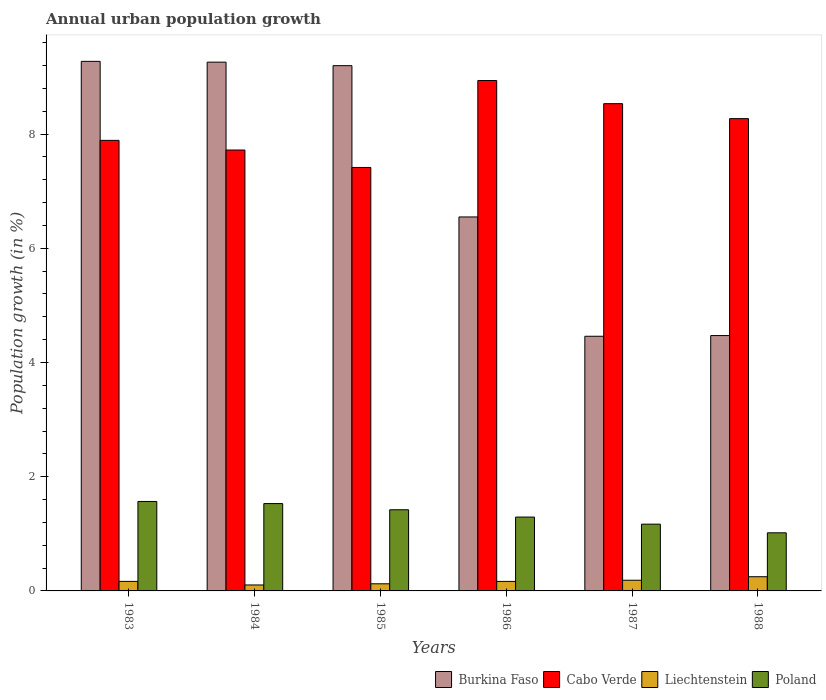How many different coloured bars are there?
Your answer should be compact. 4. Are the number of bars per tick equal to the number of legend labels?
Provide a succinct answer. Yes. What is the label of the 6th group of bars from the left?
Offer a terse response. 1988. What is the percentage of urban population growth in Liechtenstein in 1984?
Keep it short and to the point. 0.1. Across all years, what is the maximum percentage of urban population growth in Poland?
Keep it short and to the point. 1.57. Across all years, what is the minimum percentage of urban population growth in Liechtenstein?
Make the answer very short. 0.1. In which year was the percentage of urban population growth in Burkina Faso maximum?
Your response must be concise. 1983. What is the total percentage of urban population growth in Poland in the graph?
Provide a short and direct response. 8. What is the difference between the percentage of urban population growth in Poland in 1984 and that in 1987?
Make the answer very short. 0.36. What is the difference between the percentage of urban population growth in Burkina Faso in 1988 and the percentage of urban population growth in Poland in 1987?
Keep it short and to the point. 3.3. What is the average percentage of urban population growth in Burkina Faso per year?
Your response must be concise. 7.2. In the year 1984, what is the difference between the percentage of urban population growth in Burkina Faso and percentage of urban population growth in Liechtenstein?
Make the answer very short. 9.15. What is the ratio of the percentage of urban population growth in Cabo Verde in 1984 to that in 1988?
Keep it short and to the point. 0.93. Is the percentage of urban population growth in Burkina Faso in 1987 less than that in 1988?
Your answer should be very brief. Yes. Is the difference between the percentage of urban population growth in Burkina Faso in 1984 and 1986 greater than the difference between the percentage of urban population growth in Liechtenstein in 1984 and 1986?
Ensure brevity in your answer.  Yes. What is the difference between the highest and the second highest percentage of urban population growth in Poland?
Your response must be concise. 0.04. What is the difference between the highest and the lowest percentage of urban population growth in Burkina Faso?
Make the answer very short. 4.81. In how many years, is the percentage of urban population growth in Poland greater than the average percentage of urban population growth in Poland taken over all years?
Offer a very short reply. 3. Is it the case that in every year, the sum of the percentage of urban population growth in Poland and percentage of urban population growth in Burkina Faso is greater than the sum of percentage of urban population growth in Cabo Verde and percentage of urban population growth in Liechtenstein?
Provide a succinct answer. Yes. What does the 3rd bar from the left in 1987 represents?
Offer a very short reply. Liechtenstein. What does the 2nd bar from the right in 1983 represents?
Give a very brief answer. Liechtenstein. Is it the case that in every year, the sum of the percentage of urban population growth in Burkina Faso and percentage of urban population growth in Poland is greater than the percentage of urban population growth in Cabo Verde?
Keep it short and to the point. No. How many bars are there?
Provide a succinct answer. 24. How many years are there in the graph?
Provide a succinct answer. 6. Are the values on the major ticks of Y-axis written in scientific E-notation?
Your response must be concise. No. Does the graph contain grids?
Provide a short and direct response. No. What is the title of the graph?
Keep it short and to the point. Annual urban population growth. Does "Fiji" appear as one of the legend labels in the graph?
Make the answer very short. No. What is the label or title of the Y-axis?
Your answer should be compact. Population growth (in %). What is the Population growth (in %) in Burkina Faso in 1983?
Your response must be concise. 9.27. What is the Population growth (in %) in Cabo Verde in 1983?
Your answer should be very brief. 7.89. What is the Population growth (in %) of Liechtenstein in 1983?
Make the answer very short. 0.17. What is the Population growth (in %) in Poland in 1983?
Your answer should be very brief. 1.57. What is the Population growth (in %) in Burkina Faso in 1984?
Offer a terse response. 9.26. What is the Population growth (in %) of Cabo Verde in 1984?
Provide a short and direct response. 7.72. What is the Population growth (in %) in Liechtenstein in 1984?
Your response must be concise. 0.1. What is the Population growth (in %) of Poland in 1984?
Your answer should be compact. 1.53. What is the Population growth (in %) of Burkina Faso in 1985?
Your response must be concise. 9.2. What is the Population growth (in %) of Cabo Verde in 1985?
Keep it short and to the point. 7.41. What is the Population growth (in %) in Liechtenstein in 1985?
Provide a short and direct response. 0.13. What is the Population growth (in %) in Poland in 1985?
Your answer should be compact. 1.42. What is the Population growth (in %) of Burkina Faso in 1986?
Your answer should be very brief. 6.55. What is the Population growth (in %) in Cabo Verde in 1986?
Your response must be concise. 8.94. What is the Population growth (in %) in Liechtenstein in 1986?
Provide a succinct answer. 0.17. What is the Population growth (in %) in Poland in 1986?
Provide a succinct answer. 1.29. What is the Population growth (in %) in Burkina Faso in 1987?
Provide a short and direct response. 4.46. What is the Population growth (in %) of Cabo Verde in 1987?
Your answer should be compact. 8.53. What is the Population growth (in %) in Liechtenstein in 1987?
Provide a succinct answer. 0.19. What is the Population growth (in %) of Poland in 1987?
Give a very brief answer. 1.17. What is the Population growth (in %) in Burkina Faso in 1988?
Provide a succinct answer. 4.47. What is the Population growth (in %) of Cabo Verde in 1988?
Keep it short and to the point. 8.27. What is the Population growth (in %) of Liechtenstein in 1988?
Provide a succinct answer. 0.25. What is the Population growth (in %) of Poland in 1988?
Keep it short and to the point. 1.02. Across all years, what is the maximum Population growth (in %) in Burkina Faso?
Your answer should be compact. 9.27. Across all years, what is the maximum Population growth (in %) of Cabo Verde?
Provide a succinct answer. 8.94. Across all years, what is the maximum Population growth (in %) in Liechtenstein?
Give a very brief answer. 0.25. Across all years, what is the maximum Population growth (in %) of Poland?
Offer a terse response. 1.57. Across all years, what is the minimum Population growth (in %) in Burkina Faso?
Provide a succinct answer. 4.46. Across all years, what is the minimum Population growth (in %) of Cabo Verde?
Ensure brevity in your answer.  7.41. Across all years, what is the minimum Population growth (in %) of Liechtenstein?
Ensure brevity in your answer.  0.1. Across all years, what is the minimum Population growth (in %) of Poland?
Give a very brief answer. 1.02. What is the total Population growth (in %) of Burkina Faso in the graph?
Provide a short and direct response. 43.21. What is the total Population growth (in %) in Cabo Verde in the graph?
Provide a short and direct response. 48.76. What is the total Population growth (in %) in Liechtenstein in the graph?
Make the answer very short. 1. What is the total Population growth (in %) of Poland in the graph?
Keep it short and to the point. 8. What is the difference between the Population growth (in %) of Burkina Faso in 1983 and that in 1984?
Provide a succinct answer. 0.01. What is the difference between the Population growth (in %) in Cabo Verde in 1983 and that in 1984?
Offer a very short reply. 0.17. What is the difference between the Population growth (in %) in Liechtenstein in 1983 and that in 1984?
Give a very brief answer. 0.06. What is the difference between the Population growth (in %) in Poland in 1983 and that in 1984?
Provide a succinct answer. 0.04. What is the difference between the Population growth (in %) in Burkina Faso in 1983 and that in 1985?
Give a very brief answer. 0.08. What is the difference between the Population growth (in %) in Cabo Verde in 1983 and that in 1985?
Make the answer very short. 0.47. What is the difference between the Population growth (in %) in Liechtenstein in 1983 and that in 1985?
Ensure brevity in your answer.  0.04. What is the difference between the Population growth (in %) in Poland in 1983 and that in 1985?
Ensure brevity in your answer.  0.15. What is the difference between the Population growth (in %) of Burkina Faso in 1983 and that in 1986?
Provide a succinct answer. 2.72. What is the difference between the Population growth (in %) of Cabo Verde in 1983 and that in 1986?
Your answer should be compact. -1.05. What is the difference between the Population growth (in %) of Liechtenstein in 1983 and that in 1986?
Your answer should be compact. 0. What is the difference between the Population growth (in %) in Poland in 1983 and that in 1986?
Offer a very short reply. 0.27. What is the difference between the Population growth (in %) of Burkina Faso in 1983 and that in 1987?
Make the answer very short. 4.81. What is the difference between the Population growth (in %) of Cabo Verde in 1983 and that in 1987?
Give a very brief answer. -0.64. What is the difference between the Population growth (in %) in Liechtenstein in 1983 and that in 1987?
Offer a terse response. -0.02. What is the difference between the Population growth (in %) of Poland in 1983 and that in 1987?
Provide a succinct answer. 0.4. What is the difference between the Population growth (in %) in Burkina Faso in 1983 and that in 1988?
Your response must be concise. 4.8. What is the difference between the Population growth (in %) of Cabo Verde in 1983 and that in 1988?
Your answer should be compact. -0.38. What is the difference between the Population growth (in %) of Liechtenstein in 1983 and that in 1988?
Offer a terse response. -0.08. What is the difference between the Population growth (in %) of Poland in 1983 and that in 1988?
Your answer should be very brief. 0.55. What is the difference between the Population growth (in %) of Burkina Faso in 1984 and that in 1985?
Provide a succinct answer. 0.06. What is the difference between the Population growth (in %) in Cabo Verde in 1984 and that in 1985?
Ensure brevity in your answer.  0.31. What is the difference between the Population growth (in %) in Liechtenstein in 1984 and that in 1985?
Offer a very short reply. -0.02. What is the difference between the Population growth (in %) in Poland in 1984 and that in 1985?
Give a very brief answer. 0.11. What is the difference between the Population growth (in %) of Burkina Faso in 1984 and that in 1986?
Provide a short and direct response. 2.71. What is the difference between the Population growth (in %) in Cabo Verde in 1984 and that in 1986?
Ensure brevity in your answer.  -1.22. What is the difference between the Population growth (in %) in Liechtenstein in 1984 and that in 1986?
Give a very brief answer. -0.06. What is the difference between the Population growth (in %) of Poland in 1984 and that in 1986?
Ensure brevity in your answer.  0.24. What is the difference between the Population growth (in %) of Burkina Faso in 1984 and that in 1987?
Your answer should be very brief. 4.8. What is the difference between the Population growth (in %) of Cabo Verde in 1984 and that in 1987?
Provide a succinct answer. -0.81. What is the difference between the Population growth (in %) in Liechtenstein in 1984 and that in 1987?
Give a very brief answer. -0.08. What is the difference between the Population growth (in %) of Poland in 1984 and that in 1987?
Make the answer very short. 0.36. What is the difference between the Population growth (in %) of Burkina Faso in 1984 and that in 1988?
Your answer should be very brief. 4.79. What is the difference between the Population growth (in %) in Cabo Verde in 1984 and that in 1988?
Your answer should be very brief. -0.55. What is the difference between the Population growth (in %) of Liechtenstein in 1984 and that in 1988?
Give a very brief answer. -0.14. What is the difference between the Population growth (in %) in Poland in 1984 and that in 1988?
Your response must be concise. 0.51. What is the difference between the Population growth (in %) in Burkina Faso in 1985 and that in 1986?
Ensure brevity in your answer.  2.65. What is the difference between the Population growth (in %) in Cabo Verde in 1985 and that in 1986?
Your answer should be very brief. -1.52. What is the difference between the Population growth (in %) in Liechtenstein in 1985 and that in 1986?
Provide a short and direct response. -0.04. What is the difference between the Population growth (in %) of Poland in 1985 and that in 1986?
Your answer should be very brief. 0.13. What is the difference between the Population growth (in %) of Burkina Faso in 1985 and that in 1987?
Keep it short and to the point. 4.74. What is the difference between the Population growth (in %) of Cabo Verde in 1985 and that in 1987?
Offer a very short reply. -1.12. What is the difference between the Population growth (in %) in Liechtenstein in 1985 and that in 1987?
Offer a very short reply. -0.06. What is the difference between the Population growth (in %) of Poland in 1985 and that in 1987?
Your answer should be compact. 0.25. What is the difference between the Population growth (in %) of Burkina Faso in 1985 and that in 1988?
Give a very brief answer. 4.73. What is the difference between the Population growth (in %) in Cabo Verde in 1985 and that in 1988?
Your answer should be very brief. -0.85. What is the difference between the Population growth (in %) in Liechtenstein in 1985 and that in 1988?
Provide a succinct answer. -0.12. What is the difference between the Population growth (in %) of Poland in 1985 and that in 1988?
Offer a very short reply. 0.4. What is the difference between the Population growth (in %) in Burkina Faso in 1986 and that in 1987?
Give a very brief answer. 2.09. What is the difference between the Population growth (in %) of Cabo Verde in 1986 and that in 1987?
Offer a very short reply. 0.41. What is the difference between the Population growth (in %) in Liechtenstein in 1986 and that in 1987?
Offer a terse response. -0.02. What is the difference between the Population growth (in %) of Poland in 1986 and that in 1987?
Provide a succinct answer. 0.12. What is the difference between the Population growth (in %) of Burkina Faso in 1986 and that in 1988?
Ensure brevity in your answer.  2.08. What is the difference between the Population growth (in %) of Cabo Verde in 1986 and that in 1988?
Your response must be concise. 0.67. What is the difference between the Population growth (in %) of Liechtenstein in 1986 and that in 1988?
Provide a succinct answer. -0.08. What is the difference between the Population growth (in %) in Poland in 1986 and that in 1988?
Keep it short and to the point. 0.28. What is the difference between the Population growth (in %) in Burkina Faso in 1987 and that in 1988?
Keep it short and to the point. -0.01. What is the difference between the Population growth (in %) of Cabo Verde in 1987 and that in 1988?
Keep it short and to the point. 0.26. What is the difference between the Population growth (in %) in Liechtenstein in 1987 and that in 1988?
Offer a very short reply. -0.06. What is the difference between the Population growth (in %) in Poland in 1987 and that in 1988?
Keep it short and to the point. 0.15. What is the difference between the Population growth (in %) of Burkina Faso in 1983 and the Population growth (in %) of Cabo Verde in 1984?
Keep it short and to the point. 1.55. What is the difference between the Population growth (in %) in Burkina Faso in 1983 and the Population growth (in %) in Liechtenstein in 1984?
Provide a short and direct response. 9.17. What is the difference between the Population growth (in %) in Burkina Faso in 1983 and the Population growth (in %) in Poland in 1984?
Give a very brief answer. 7.74. What is the difference between the Population growth (in %) in Cabo Verde in 1983 and the Population growth (in %) in Liechtenstein in 1984?
Give a very brief answer. 7.79. What is the difference between the Population growth (in %) in Cabo Verde in 1983 and the Population growth (in %) in Poland in 1984?
Offer a terse response. 6.36. What is the difference between the Population growth (in %) of Liechtenstein in 1983 and the Population growth (in %) of Poland in 1984?
Provide a short and direct response. -1.36. What is the difference between the Population growth (in %) in Burkina Faso in 1983 and the Population growth (in %) in Cabo Verde in 1985?
Give a very brief answer. 1.86. What is the difference between the Population growth (in %) of Burkina Faso in 1983 and the Population growth (in %) of Liechtenstein in 1985?
Provide a succinct answer. 9.15. What is the difference between the Population growth (in %) of Burkina Faso in 1983 and the Population growth (in %) of Poland in 1985?
Keep it short and to the point. 7.85. What is the difference between the Population growth (in %) of Cabo Verde in 1983 and the Population growth (in %) of Liechtenstein in 1985?
Your answer should be compact. 7.76. What is the difference between the Population growth (in %) in Cabo Verde in 1983 and the Population growth (in %) in Poland in 1985?
Keep it short and to the point. 6.47. What is the difference between the Population growth (in %) of Liechtenstein in 1983 and the Population growth (in %) of Poland in 1985?
Keep it short and to the point. -1.25. What is the difference between the Population growth (in %) in Burkina Faso in 1983 and the Population growth (in %) in Cabo Verde in 1986?
Your response must be concise. 0.34. What is the difference between the Population growth (in %) of Burkina Faso in 1983 and the Population growth (in %) of Liechtenstein in 1986?
Your response must be concise. 9.11. What is the difference between the Population growth (in %) of Burkina Faso in 1983 and the Population growth (in %) of Poland in 1986?
Your answer should be compact. 7.98. What is the difference between the Population growth (in %) in Cabo Verde in 1983 and the Population growth (in %) in Liechtenstein in 1986?
Give a very brief answer. 7.72. What is the difference between the Population growth (in %) in Cabo Verde in 1983 and the Population growth (in %) in Poland in 1986?
Your response must be concise. 6.6. What is the difference between the Population growth (in %) of Liechtenstein in 1983 and the Population growth (in %) of Poland in 1986?
Make the answer very short. -1.13. What is the difference between the Population growth (in %) in Burkina Faso in 1983 and the Population growth (in %) in Cabo Verde in 1987?
Provide a short and direct response. 0.74. What is the difference between the Population growth (in %) in Burkina Faso in 1983 and the Population growth (in %) in Liechtenstein in 1987?
Your response must be concise. 9.09. What is the difference between the Population growth (in %) in Burkina Faso in 1983 and the Population growth (in %) in Poland in 1987?
Provide a short and direct response. 8.1. What is the difference between the Population growth (in %) of Cabo Verde in 1983 and the Population growth (in %) of Liechtenstein in 1987?
Keep it short and to the point. 7.7. What is the difference between the Population growth (in %) in Cabo Verde in 1983 and the Population growth (in %) in Poland in 1987?
Make the answer very short. 6.72. What is the difference between the Population growth (in %) of Liechtenstein in 1983 and the Population growth (in %) of Poland in 1987?
Offer a very short reply. -1. What is the difference between the Population growth (in %) of Burkina Faso in 1983 and the Population growth (in %) of Liechtenstein in 1988?
Keep it short and to the point. 9.02. What is the difference between the Population growth (in %) in Burkina Faso in 1983 and the Population growth (in %) in Poland in 1988?
Provide a short and direct response. 8.26. What is the difference between the Population growth (in %) of Cabo Verde in 1983 and the Population growth (in %) of Liechtenstein in 1988?
Make the answer very short. 7.64. What is the difference between the Population growth (in %) in Cabo Verde in 1983 and the Population growth (in %) in Poland in 1988?
Your answer should be compact. 6.87. What is the difference between the Population growth (in %) of Liechtenstein in 1983 and the Population growth (in %) of Poland in 1988?
Ensure brevity in your answer.  -0.85. What is the difference between the Population growth (in %) in Burkina Faso in 1984 and the Population growth (in %) in Cabo Verde in 1985?
Provide a succinct answer. 1.84. What is the difference between the Population growth (in %) in Burkina Faso in 1984 and the Population growth (in %) in Liechtenstein in 1985?
Ensure brevity in your answer.  9.13. What is the difference between the Population growth (in %) in Burkina Faso in 1984 and the Population growth (in %) in Poland in 1985?
Provide a short and direct response. 7.84. What is the difference between the Population growth (in %) in Cabo Verde in 1984 and the Population growth (in %) in Liechtenstein in 1985?
Provide a short and direct response. 7.6. What is the difference between the Population growth (in %) in Cabo Verde in 1984 and the Population growth (in %) in Poland in 1985?
Your response must be concise. 6.3. What is the difference between the Population growth (in %) in Liechtenstein in 1984 and the Population growth (in %) in Poland in 1985?
Offer a terse response. -1.32. What is the difference between the Population growth (in %) in Burkina Faso in 1984 and the Population growth (in %) in Cabo Verde in 1986?
Your answer should be compact. 0.32. What is the difference between the Population growth (in %) of Burkina Faso in 1984 and the Population growth (in %) of Liechtenstein in 1986?
Your answer should be compact. 9.09. What is the difference between the Population growth (in %) in Burkina Faso in 1984 and the Population growth (in %) in Poland in 1986?
Provide a succinct answer. 7.97. What is the difference between the Population growth (in %) in Cabo Verde in 1984 and the Population growth (in %) in Liechtenstein in 1986?
Keep it short and to the point. 7.55. What is the difference between the Population growth (in %) in Cabo Verde in 1984 and the Population growth (in %) in Poland in 1986?
Provide a short and direct response. 6.43. What is the difference between the Population growth (in %) of Liechtenstein in 1984 and the Population growth (in %) of Poland in 1986?
Offer a terse response. -1.19. What is the difference between the Population growth (in %) of Burkina Faso in 1984 and the Population growth (in %) of Cabo Verde in 1987?
Make the answer very short. 0.73. What is the difference between the Population growth (in %) of Burkina Faso in 1984 and the Population growth (in %) of Liechtenstein in 1987?
Offer a terse response. 9.07. What is the difference between the Population growth (in %) of Burkina Faso in 1984 and the Population growth (in %) of Poland in 1987?
Provide a succinct answer. 8.09. What is the difference between the Population growth (in %) of Cabo Verde in 1984 and the Population growth (in %) of Liechtenstein in 1987?
Ensure brevity in your answer.  7.53. What is the difference between the Population growth (in %) of Cabo Verde in 1984 and the Population growth (in %) of Poland in 1987?
Your answer should be very brief. 6.55. What is the difference between the Population growth (in %) in Liechtenstein in 1984 and the Population growth (in %) in Poland in 1987?
Ensure brevity in your answer.  -1.06. What is the difference between the Population growth (in %) of Burkina Faso in 1984 and the Population growth (in %) of Cabo Verde in 1988?
Provide a short and direct response. 0.99. What is the difference between the Population growth (in %) of Burkina Faso in 1984 and the Population growth (in %) of Liechtenstein in 1988?
Offer a terse response. 9.01. What is the difference between the Population growth (in %) in Burkina Faso in 1984 and the Population growth (in %) in Poland in 1988?
Ensure brevity in your answer.  8.24. What is the difference between the Population growth (in %) in Cabo Verde in 1984 and the Population growth (in %) in Liechtenstein in 1988?
Provide a succinct answer. 7.47. What is the difference between the Population growth (in %) in Cabo Verde in 1984 and the Population growth (in %) in Poland in 1988?
Offer a very short reply. 6.7. What is the difference between the Population growth (in %) in Liechtenstein in 1984 and the Population growth (in %) in Poland in 1988?
Keep it short and to the point. -0.91. What is the difference between the Population growth (in %) in Burkina Faso in 1985 and the Population growth (in %) in Cabo Verde in 1986?
Offer a terse response. 0.26. What is the difference between the Population growth (in %) in Burkina Faso in 1985 and the Population growth (in %) in Liechtenstein in 1986?
Offer a very short reply. 9.03. What is the difference between the Population growth (in %) of Burkina Faso in 1985 and the Population growth (in %) of Poland in 1986?
Ensure brevity in your answer.  7.9. What is the difference between the Population growth (in %) in Cabo Verde in 1985 and the Population growth (in %) in Liechtenstein in 1986?
Your answer should be very brief. 7.25. What is the difference between the Population growth (in %) in Cabo Verde in 1985 and the Population growth (in %) in Poland in 1986?
Give a very brief answer. 6.12. What is the difference between the Population growth (in %) of Liechtenstein in 1985 and the Population growth (in %) of Poland in 1986?
Offer a terse response. -1.17. What is the difference between the Population growth (in %) of Burkina Faso in 1985 and the Population growth (in %) of Cabo Verde in 1987?
Give a very brief answer. 0.67. What is the difference between the Population growth (in %) in Burkina Faso in 1985 and the Population growth (in %) in Liechtenstein in 1987?
Ensure brevity in your answer.  9.01. What is the difference between the Population growth (in %) of Burkina Faso in 1985 and the Population growth (in %) of Poland in 1987?
Your answer should be very brief. 8.03. What is the difference between the Population growth (in %) of Cabo Verde in 1985 and the Population growth (in %) of Liechtenstein in 1987?
Offer a very short reply. 7.23. What is the difference between the Population growth (in %) of Cabo Verde in 1985 and the Population growth (in %) of Poland in 1987?
Your response must be concise. 6.25. What is the difference between the Population growth (in %) in Liechtenstein in 1985 and the Population growth (in %) in Poland in 1987?
Offer a terse response. -1.04. What is the difference between the Population growth (in %) in Burkina Faso in 1985 and the Population growth (in %) in Cabo Verde in 1988?
Your answer should be very brief. 0.93. What is the difference between the Population growth (in %) of Burkina Faso in 1985 and the Population growth (in %) of Liechtenstein in 1988?
Provide a short and direct response. 8.95. What is the difference between the Population growth (in %) of Burkina Faso in 1985 and the Population growth (in %) of Poland in 1988?
Make the answer very short. 8.18. What is the difference between the Population growth (in %) in Cabo Verde in 1985 and the Population growth (in %) in Liechtenstein in 1988?
Make the answer very short. 7.17. What is the difference between the Population growth (in %) of Cabo Verde in 1985 and the Population growth (in %) of Poland in 1988?
Offer a terse response. 6.4. What is the difference between the Population growth (in %) of Liechtenstein in 1985 and the Population growth (in %) of Poland in 1988?
Offer a terse response. -0.89. What is the difference between the Population growth (in %) of Burkina Faso in 1986 and the Population growth (in %) of Cabo Verde in 1987?
Offer a terse response. -1.98. What is the difference between the Population growth (in %) of Burkina Faso in 1986 and the Population growth (in %) of Liechtenstein in 1987?
Give a very brief answer. 6.36. What is the difference between the Population growth (in %) in Burkina Faso in 1986 and the Population growth (in %) in Poland in 1987?
Give a very brief answer. 5.38. What is the difference between the Population growth (in %) in Cabo Verde in 1986 and the Population growth (in %) in Liechtenstein in 1987?
Your response must be concise. 8.75. What is the difference between the Population growth (in %) in Cabo Verde in 1986 and the Population growth (in %) in Poland in 1987?
Your answer should be very brief. 7.77. What is the difference between the Population growth (in %) of Liechtenstein in 1986 and the Population growth (in %) of Poland in 1987?
Ensure brevity in your answer.  -1. What is the difference between the Population growth (in %) of Burkina Faso in 1986 and the Population growth (in %) of Cabo Verde in 1988?
Your answer should be very brief. -1.72. What is the difference between the Population growth (in %) in Burkina Faso in 1986 and the Population growth (in %) in Liechtenstein in 1988?
Your answer should be very brief. 6.3. What is the difference between the Population growth (in %) of Burkina Faso in 1986 and the Population growth (in %) of Poland in 1988?
Your answer should be very brief. 5.53. What is the difference between the Population growth (in %) of Cabo Verde in 1986 and the Population growth (in %) of Liechtenstein in 1988?
Give a very brief answer. 8.69. What is the difference between the Population growth (in %) in Cabo Verde in 1986 and the Population growth (in %) in Poland in 1988?
Ensure brevity in your answer.  7.92. What is the difference between the Population growth (in %) in Liechtenstein in 1986 and the Population growth (in %) in Poland in 1988?
Keep it short and to the point. -0.85. What is the difference between the Population growth (in %) of Burkina Faso in 1987 and the Population growth (in %) of Cabo Verde in 1988?
Give a very brief answer. -3.81. What is the difference between the Population growth (in %) in Burkina Faso in 1987 and the Population growth (in %) in Liechtenstein in 1988?
Offer a very short reply. 4.21. What is the difference between the Population growth (in %) in Burkina Faso in 1987 and the Population growth (in %) in Poland in 1988?
Provide a short and direct response. 3.44. What is the difference between the Population growth (in %) in Cabo Verde in 1987 and the Population growth (in %) in Liechtenstein in 1988?
Give a very brief answer. 8.28. What is the difference between the Population growth (in %) of Cabo Verde in 1987 and the Population growth (in %) of Poland in 1988?
Keep it short and to the point. 7.51. What is the difference between the Population growth (in %) of Liechtenstein in 1987 and the Population growth (in %) of Poland in 1988?
Your answer should be compact. -0.83. What is the average Population growth (in %) of Burkina Faso per year?
Keep it short and to the point. 7.2. What is the average Population growth (in %) in Cabo Verde per year?
Keep it short and to the point. 8.13. What is the average Population growth (in %) of Liechtenstein per year?
Provide a succinct answer. 0.17. What is the average Population growth (in %) in Poland per year?
Your answer should be compact. 1.33. In the year 1983, what is the difference between the Population growth (in %) in Burkina Faso and Population growth (in %) in Cabo Verde?
Offer a terse response. 1.38. In the year 1983, what is the difference between the Population growth (in %) of Burkina Faso and Population growth (in %) of Liechtenstein?
Make the answer very short. 9.11. In the year 1983, what is the difference between the Population growth (in %) in Burkina Faso and Population growth (in %) in Poland?
Your answer should be very brief. 7.71. In the year 1983, what is the difference between the Population growth (in %) of Cabo Verde and Population growth (in %) of Liechtenstein?
Keep it short and to the point. 7.72. In the year 1983, what is the difference between the Population growth (in %) in Cabo Verde and Population growth (in %) in Poland?
Your response must be concise. 6.32. In the year 1983, what is the difference between the Population growth (in %) of Liechtenstein and Population growth (in %) of Poland?
Your response must be concise. -1.4. In the year 1984, what is the difference between the Population growth (in %) of Burkina Faso and Population growth (in %) of Cabo Verde?
Keep it short and to the point. 1.54. In the year 1984, what is the difference between the Population growth (in %) of Burkina Faso and Population growth (in %) of Liechtenstein?
Make the answer very short. 9.15. In the year 1984, what is the difference between the Population growth (in %) in Burkina Faso and Population growth (in %) in Poland?
Give a very brief answer. 7.73. In the year 1984, what is the difference between the Population growth (in %) of Cabo Verde and Population growth (in %) of Liechtenstein?
Ensure brevity in your answer.  7.62. In the year 1984, what is the difference between the Population growth (in %) of Cabo Verde and Population growth (in %) of Poland?
Provide a succinct answer. 6.19. In the year 1984, what is the difference between the Population growth (in %) of Liechtenstein and Population growth (in %) of Poland?
Your response must be concise. -1.43. In the year 1985, what is the difference between the Population growth (in %) of Burkina Faso and Population growth (in %) of Cabo Verde?
Your response must be concise. 1.78. In the year 1985, what is the difference between the Population growth (in %) of Burkina Faso and Population growth (in %) of Liechtenstein?
Keep it short and to the point. 9.07. In the year 1985, what is the difference between the Population growth (in %) of Burkina Faso and Population growth (in %) of Poland?
Your answer should be compact. 7.78. In the year 1985, what is the difference between the Population growth (in %) of Cabo Verde and Population growth (in %) of Liechtenstein?
Offer a terse response. 7.29. In the year 1985, what is the difference between the Population growth (in %) in Cabo Verde and Population growth (in %) in Poland?
Your answer should be compact. 5.99. In the year 1985, what is the difference between the Population growth (in %) in Liechtenstein and Population growth (in %) in Poland?
Give a very brief answer. -1.3. In the year 1986, what is the difference between the Population growth (in %) in Burkina Faso and Population growth (in %) in Cabo Verde?
Your answer should be compact. -2.39. In the year 1986, what is the difference between the Population growth (in %) of Burkina Faso and Population growth (in %) of Liechtenstein?
Provide a short and direct response. 6.38. In the year 1986, what is the difference between the Population growth (in %) in Burkina Faso and Population growth (in %) in Poland?
Keep it short and to the point. 5.26. In the year 1986, what is the difference between the Population growth (in %) in Cabo Verde and Population growth (in %) in Liechtenstein?
Your answer should be very brief. 8.77. In the year 1986, what is the difference between the Population growth (in %) of Cabo Verde and Population growth (in %) of Poland?
Offer a terse response. 7.64. In the year 1986, what is the difference between the Population growth (in %) of Liechtenstein and Population growth (in %) of Poland?
Your response must be concise. -1.13. In the year 1987, what is the difference between the Population growth (in %) of Burkina Faso and Population growth (in %) of Cabo Verde?
Provide a succinct answer. -4.07. In the year 1987, what is the difference between the Population growth (in %) of Burkina Faso and Population growth (in %) of Liechtenstein?
Your answer should be compact. 4.27. In the year 1987, what is the difference between the Population growth (in %) of Burkina Faso and Population growth (in %) of Poland?
Offer a terse response. 3.29. In the year 1987, what is the difference between the Population growth (in %) in Cabo Verde and Population growth (in %) in Liechtenstein?
Give a very brief answer. 8.34. In the year 1987, what is the difference between the Population growth (in %) in Cabo Verde and Population growth (in %) in Poland?
Offer a terse response. 7.36. In the year 1987, what is the difference between the Population growth (in %) in Liechtenstein and Population growth (in %) in Poland?
Keep it short and to the point. -0.98. In the year 1988, what is the difference between the Population growth (in %) in Burkina Faso and Population growth (in %) in Cabo Verde?
Your response must be concise. -3.8. In the year 1988, what is the difference between the Population growth (in %) of Burkina Faso and Population growth (in %) of Liechtenstein?
Make the answer very short. 4.22. In the year 1988, what is the difference between the Population growth (in %) of Burkina Faso and Population growth (in %) of Poland?
Keep it short and to the point. 3.45. In the year 1988, what is the difference between the Population growth (in %) in Cabo Verde and Population growth (in %) in Liechtenstein?
Provide a short and direct response. 8.02. In the year 1988, what is the difference between the Population growth (in %) in Cabo Verde and Population growth (in %) in Poland?
Provide a succinct answer. 7.25. In the year 1988, what is the difference between the Population growth (in %) in Liechtenstein and Population growth (in %) in Poland?
Make the answer very short. -0.77. What is the ratio of the Population growth (in %) in Cabo Verde in 1983 to that in 1984?
Give a very brief answer. 1.02. What is the ratio of the Population growth (in %) in Liechtenstein in 1983 to that in 1984?
Ensure brevity in your answer.  1.6. What is the ratio of the Population growth (in %) of Poland in 1983 to that in 1984?
Your answer should be compact. 1.02. What is the ratio of the Population growth (in %) of Burkina Faso in 1983 to that in 1985?
Provide a succinct answer. 1.01. What is the ratio of the Population growth (in %) in Cabo Verde in 1983 to that in 1985?
Your answer should be very brief. 1.06. What is the ratio of the Population growth (in %) of Liechtenstein in 1983 to that in 1985?
Offer a terse response. 1.34. What is the ratio of the Population growth (in %) in Poland in 1983 to that in 1985?
Offer a very short reply. 1.1. What is the ratio of the Population growth (in %) of Burkina Faso in 1983 to that in 1986?
Keep it short and to the point. 1.42. What is the ratio of the Population growth (in %) in Cabo Verde in 1983 to that in 1986?
Provide a short and direct response. 0.88. What is the ratio of the Population growth (in %) of Poland in 1983 to that in 1986?
Provide a short and direct response. 1.21. What is the ratio of the Population growth (in %) in Burkina Faso in 1983 to that in 1987?
Make the answer very short. 2.08. What is the ratio of the Population growth (in %) of Cabo Verde in 1983 to that in 1987?
Offer a terse response. 0.92. What is the ratio of the Population growth (in %) of Liechtenstein in 1983 to that in 1987?
Provide a short and direct response. 0.89. What is the ratio of the Population growth (in %) in Poland in 1983 to that in 1987?
Your answer should be very brief. 1.34. What is the ratio of the Population growth (in %) of Burkina Faso in 1983 to that in 1988?
Your response must be concise. 2.07. What is the ratio of the Population growth (in %) of Cabo Verde in 1983 to that in 1988?
Provide a succinct answer. 0.95. What is the ratio of the Population growth (in %) of Liechtenstein in 1983 to that in 1988?
Ensure brevity in your answer.  0.67. What is the ratio of the Population growth (in %) of Poland in 1983 to that in 1988?
Provide a succinct answer. 1.54. What is the ratio of the Population growth (in %) in Cabo Verde in 1984 to that in 1985?
Your response must be concise. 1.04. What is the ratio of the Population growth (in %) of Liechtenstein in 1984 to that in 1985?
Offer a very short reply. 0.83. What is the ratio of the Population growth (in %) of Poland in 1984 to that in 1985?
Provide a succinct answer. 1.08. What is the ratio of the Population growth (in %) in Burkina Faso in 1984 to that in 1986?
Your response must be concise. 1.41. What is the ratio of the Population growth (in %) in Cabo Verde in 1984 to that in 1986?
Offer a very short reply. 0.86. What is the ratio of the Population growth (in %) in Liechtenstein in 1984 to that in 1986?
Your answer should be compact. 0.63. What is the ratio of the Population growth (in %) in Poland in 1984 to that in 1986?
Keep it short and to the point. 1.18. What is the ratio of the Population growth (in %) of Burkina Faso in 1984 to that in 1987?
Make the answer very short. 2.08. What is the ratio of the Population growth (in %) in Cabo Verde in 1984 to that in 1987?
Your answer should be compact. 0.9. What is the ratio of the Population growth (in %) of Liechtenstein in 1984 to that in 1987?
Offer a terse response. 0.56. What is the ratio of the Population growth (in %) in Poland in 1984 to that in 1987?
Your response must be concise. 1.31. What is the ratio of the Population growth (in %) in Burkina Faso in 1984 to that in 1988?
Provide a succinct answer. 2.07. What is the ratio of the Population growth (in %) in Cabo Verde in 1984 to that in 1988?
Provide a succinct answer. 0.93. What is the ratio of the Population growth (in %) in Liechtenstein in 1984 to that in 1988?
Ensure brevity in your answer.  0.42. What is the ratio of the Population growth (in %) in Poland in 1984 to that in 1988?
Your answer should be compact. 1.5. What is the ratio of the Population growth (in %) in Burkina Faso in 1985 to that in 1986?
Your answer should be very brief. 1.4. What is the ratio of the Population growth (in %) in Cabo Verde in 1985 to that in 1986?
Make the answer very short. 0.83. What is the ratio of the Population growth (in %) in Liechtenstein in 1985 to that in 1986?
Give a very brief answer. 0.75. What is the ratio of the Population growth (in %) in Poland in 1985 to that in 1986?
Give a very brief answer. 1.1. What is the ratio of the Population growth (in %) in Burkina Faso in 1985 to that in 1987?
Your response must be concise. 2.06. What is the ratio of the Population growth (in %) in Cabo Verde in 1985 to that in 1987?
Provide a succinct answer. 0.87. What is the ratio of the Population growth (in %) of Liechtenstein in 1985 to that in 1987?
Give a very brief answer. 0.67. What is the ratio of the Population growth (in %) in Poland in 1985 to that in 1987?
Keep it short and to the point. 1.22. What is the ratio of the Population growth (in %) of Burkina Faso in 1985 to that in 1988?
Your answer should be very brief. 2.06. What is the ratio of the Population growth (in %) in Cabo Verde in 1985 to that in 1988?
Provide a short and direct response. 0.9. What is the ratio of the Population growth (in %) of Liechtenstein in 1985 to that in 1988?
Your response must be concise. 0.5. What is the ratio of the Population growth (in %) in Poland in 1985 to that in 1988?
Give a very brief answer. 1.4. What is the ratio of the Population growth (in %) in Burkina Faso in 1986 to that in 1987?
Provide a short and direct response. 1.47. What is the ratio of the Population growth (in %) of Cabo Verde in 1986 to that in 1987?
Provide a succinct answer. 1.05. What is the ratio of the Population growth (in %) of Liechtenstein in 1986 to that in 1987?
Your answer should be very brief. 0.89. What is the ratio of the Population growth (in %) in Poland in 1986 to that in 1987?
Offer a very short reply. 1.11. What is the ratio of the Population growth (in %) in Burkina Faso in 1986 to that in 1988?
Keep it short and to the point. 1.46. What is the ratio of the Population growth (in %) of Cabo Verde in 1986 to that in 1988?
Keep it short and to the point. 1.08. What is the ratio of the Population growth (in %) of Liechtenstein in 1986 to that in 1988?
Your response must be concise. 0.67. What is the ratio of the Population growth (in %) of Poland in 1986 to that in 1988?
Give a very brief answer. 1.27. What is the ratio of the Population growth (in %) in Burkina Faso in 1987 to that in 1988?
Ensure brevity in your answer.  1. What is the ratio of the Population growth (in %) in Cabo Verde in 1987 to that in 1988?
Offer a very short reply. 1.03. What is the ratio of the Population growth (in %) in Liechtenstein in 1987 to that in 1988?
Provide a succinct answer. 0.75. What is the ratio of the Population growth (in %) of Poland in 1987 to that in 1988?
Your response must be concise. 1.15. What is the difference between the highest and the second highest Population growth (in %) of Burkina Faso?
Provide a succinct answer. 0.01. What is the difference between the highest and the second highest Population growth (in %) in Cabo Verde?
Your answer should be very brief. 0.41. What is the difference between the highest and the second highest Population growth (in %) of Liechtenstein?
Provide a succinct answer. 0.06. What is the difference between the highest and the second highest Population growth (in %) in Poland?
Keep it short and to the point. 0.04. What is the difference between the highest and the lowest Population growth (in %) of Burkina Faso?
Your response must be concise. 4.81. What is the difference between the highest and the lowest Population growth (in %) in Cabo Verde?
Keep it short and to the point. 1.52. What is the difference between the highest and the lowest Population growth (in %) of Liechtenstein?
Your response must be concise. 0.14. What is the difference between the highest and the lowest Population growth (in %) in Poland?
Give a very brief answer. 0.55. 